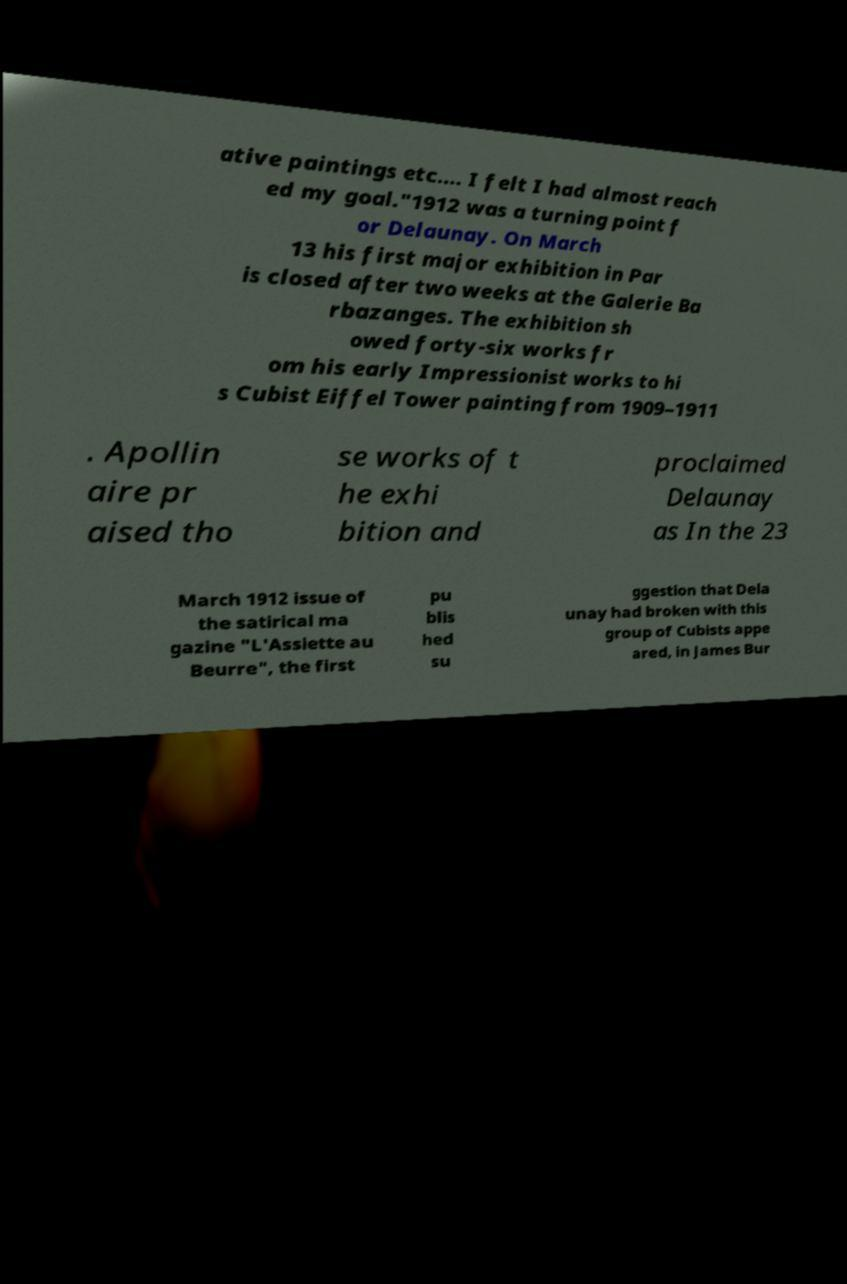Please identify and transcribe the text found in this image. ative paintings etc.… I felt I had almost reach ed my goal."1912 was a turning point f or Delaunay. On March 13 his first major exhibition in Par is closed after two weeks at the Galerie Ba rbazanges. The exhibition sh owed forty-six works fr om his early Impressionist works to hi s Cubist Eiffel Tower painting from 1909–1911 . Apollin aire pr aised tho se works of t he exhi bition and proclaimed Delaunay as In the 23 March 1912 issue of the satirical ma gazine "L'Assiette au Beurre", the first pu blis hed su ggestion that Dela unay had broken with this group of Cubists appe ared, in James Bur 